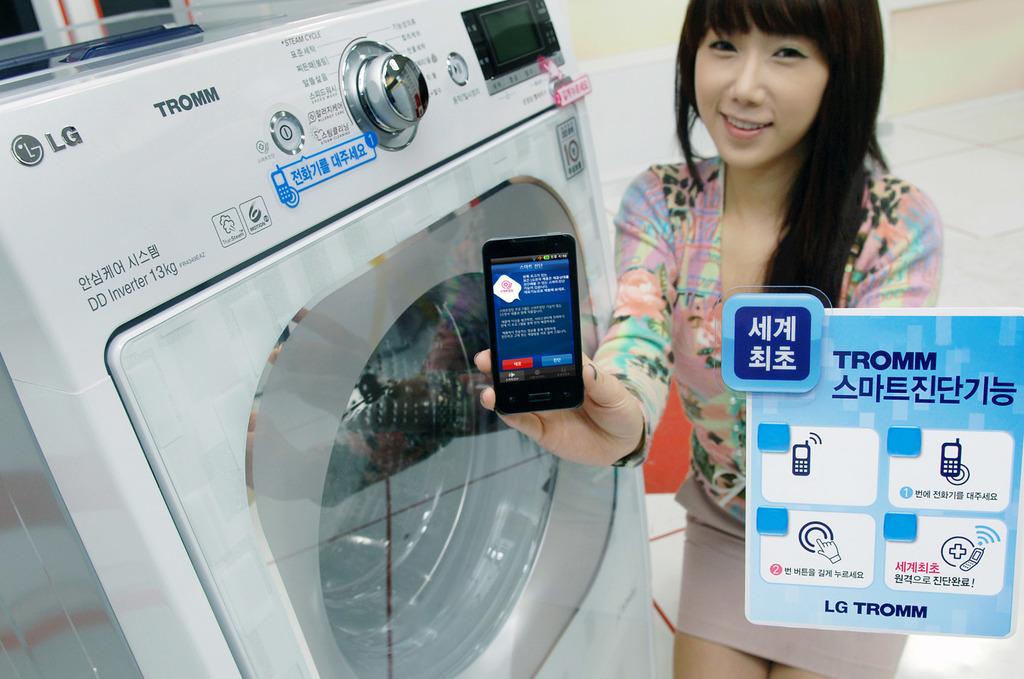What brand is this appliance?
Keep it short and to the point. Lg. 